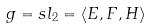<formula> <loc_0><loc_0><loc_500><loc_500>g = s l _ { 2 } = \langle E , F , H \rangle</formula> 